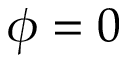Convert formula to latex. <formula><loc_0><loc_0><loc_500><loc_500>\phi = 0</formula> 